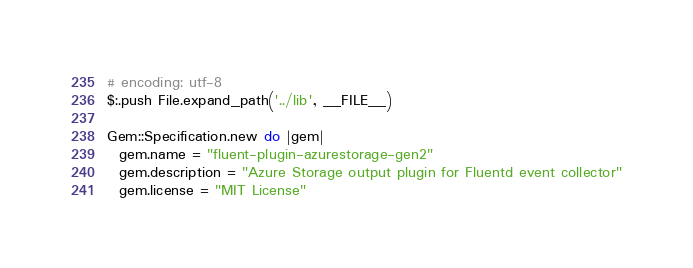<code> <loc_0><loc_0><loc_500><loc_500><_Ruby_># encoding: utf-8
$:.push File.expand_path('../lib', __FILE__)

Gem::Specification.new do |gem|
  gem.name = "fluent-plugin-azurestorage-gen2"
  gem.description = "Azure Storage output plugin for Fluentd event collector"
  gem.license = "MIT License"</code> 